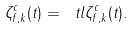<formula> <loc_0><loc_0><loc_500><loc_500>\zeta _ { f , k } ^ { c } ( t ) = \ t l { \zeta _ { f , k } ^ { c } } ( t ) .</formula> 